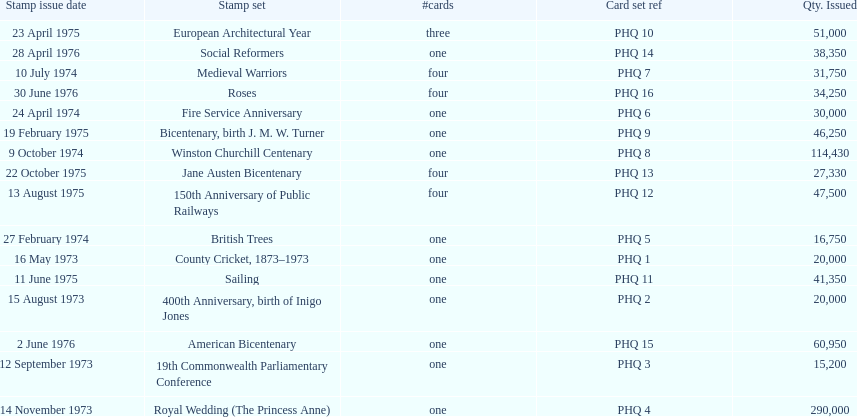Which stamp set had the greatest quantity issued? Royal Wedding (The Princess Anne). 